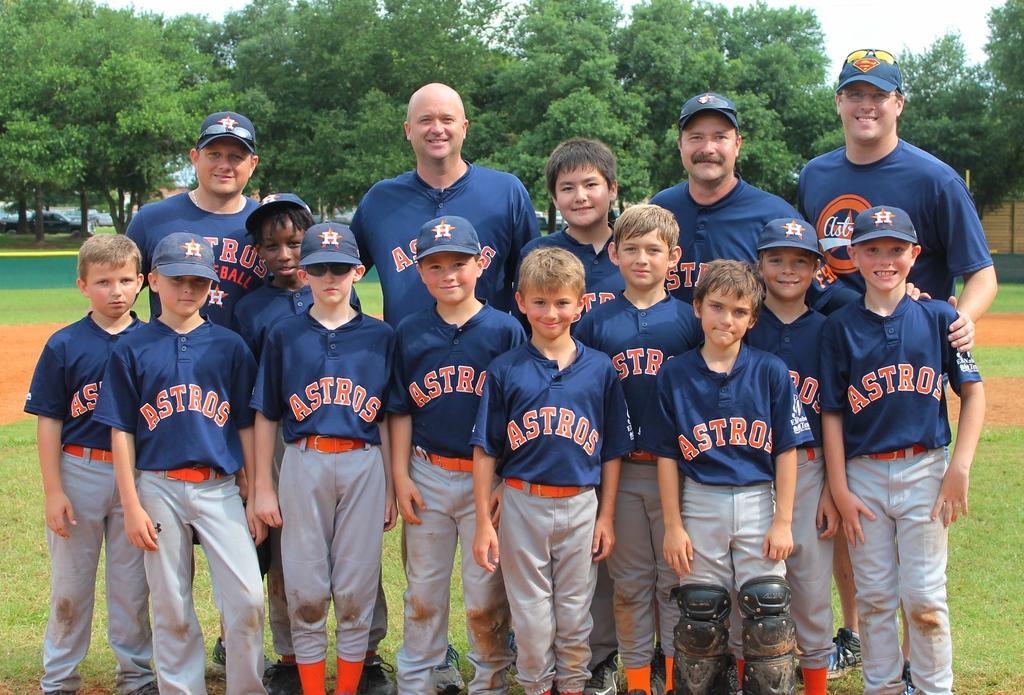Could you give a brief overview of what you see in this image? In this image in the center there are some persons standing and there are some boys standing. In the background there are some trees, and at the bottom there is grass and sand and at the top of the image there is sky. 